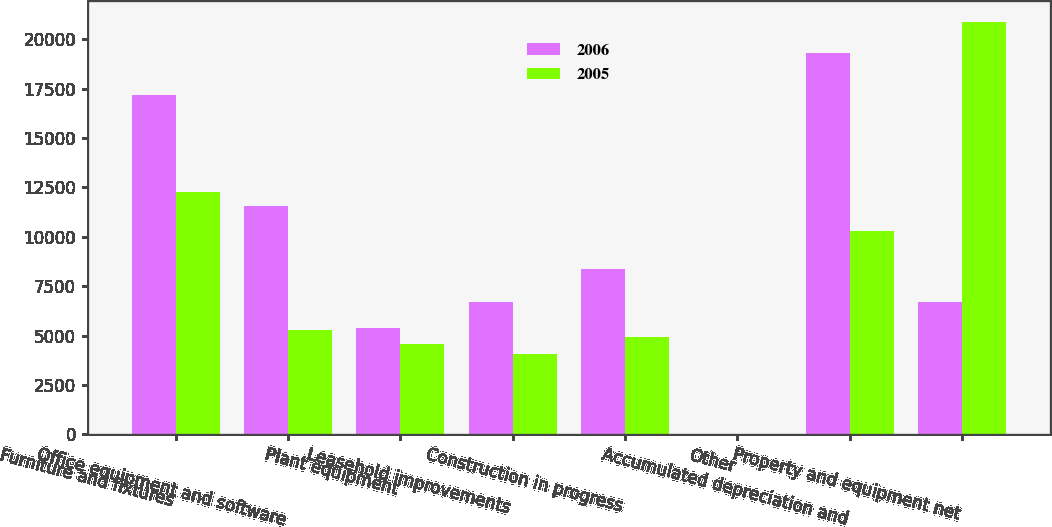Convert chart. <chart><loc_0><loc_0><loc_500><loc_500><stacked_bar_chart><ecel><fcel>Furniture and fixtures<fcel>Office equipment and software<fcel>Plant equipment<fcel>Leasehold improvements<fcel>Construction in progress<fcel>Other<fcel>Accumulated depreciation and<fcel>Property and equipment net<nl><fcel>2006<fcel>17178<fcel>11567<fcel>5401<fcel>6700<fcel>8346<fcel>24<fcel>19293<fcel>6700<nl><fcel>2005<fcel>12262<fcel>5290<fcel>4582<fcel>4058<fcel>4917<fcel>24<fcel>10268<fcel>20865<nl></chart> 